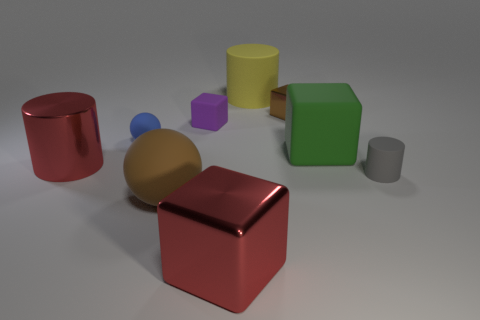Subtract all large red cubes. How many cubes are left? 3 Subtract all green cubes. How many cubes are left? 3 Add 1 purple objects. How many objects exist? 10 Subtract 1 cylinders. How many cylinders are left? 2 Add 5 blue metal balls. How many blue metal balls exist? 5 Subtract 0 purple spheres. How many objects are left? 9 Subtract all blocks. How many objects are left? 5 Subtract all purple cubes. Subtract all red spheres. How many cubes are left? 3 Subtract all blue cylinders. How many red balls are left? 0 Subtract all big blue things. Subtract all matte cubes. How many objects are left? 7 